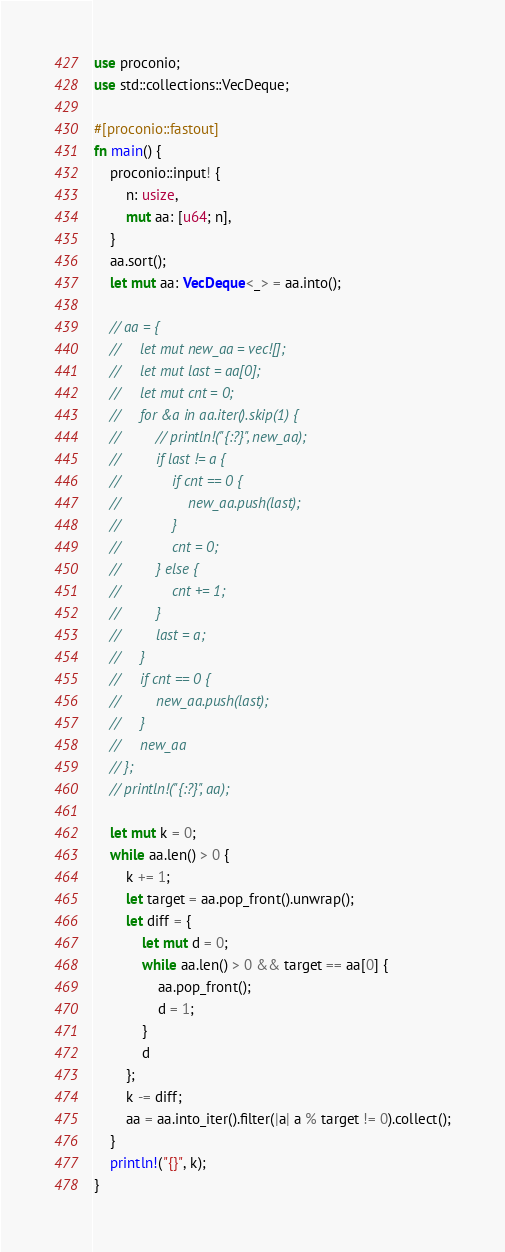<code> <loc_0><loc_0><loc_500><loc_500><_Rust_>use proconio;
use std::collections::VecDeque;

#[proconio::fastout]
fn main() {
    proconio::input! {
        n: usize,
        mut aa: [u64; n],
    }
    aa.sort();
    let mut aa: VecDeque<_> = aa.into();

    // aa = {
    //     let mut new_aa = vec![];
    //     let mut last = aa[0];
    //     let mut cnt = 0;
    //     for &a in aa.iter().skip(1) {
    //         // println!("{:?}", new_aa);
    //         if last != a {
    //             if cnt == 0 {
    //                 new_aa.push(last);
    //             }
    //             cnt = 0;
    //         } else {
    //             cnt += 1;
    //         }
    //         last = a;
    //     }
    //     if cnt == 0 {
    //         new_aa.push(last);
    //     }
    //     new_aa
    // };
    // println!("{:?}", aa);

    let mut k = 0;
    while aa.len() > 0 {
        k += 1;
        let target = aa.pop_front().unwrap();
        let diff = {
            let mut d = 0;
            while aa.len() > 0 && target == aa[0] {
                aa.pop_front();
                d = 1;
            }
            d
        };
        k -= diff;
        aa = aa.into_iter().filter(|a| a % target != 0).collect();
    }
    println!("{}", k);
}
</code> 